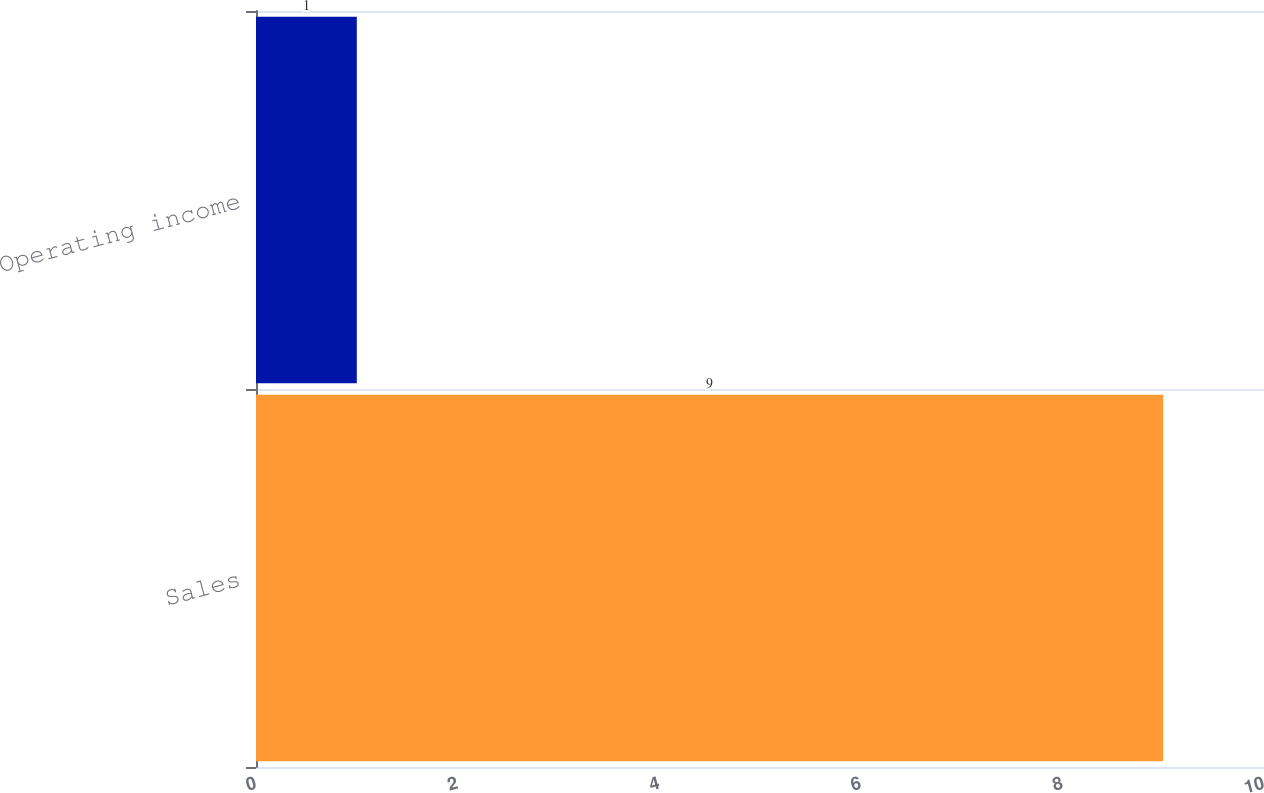<chart> <loc_0><loc_0><loc_500><loc_500><bar_chart><fcel>Sales<fcel>Operating income<nl><fcel>9<fcel>1<nl></chart> 